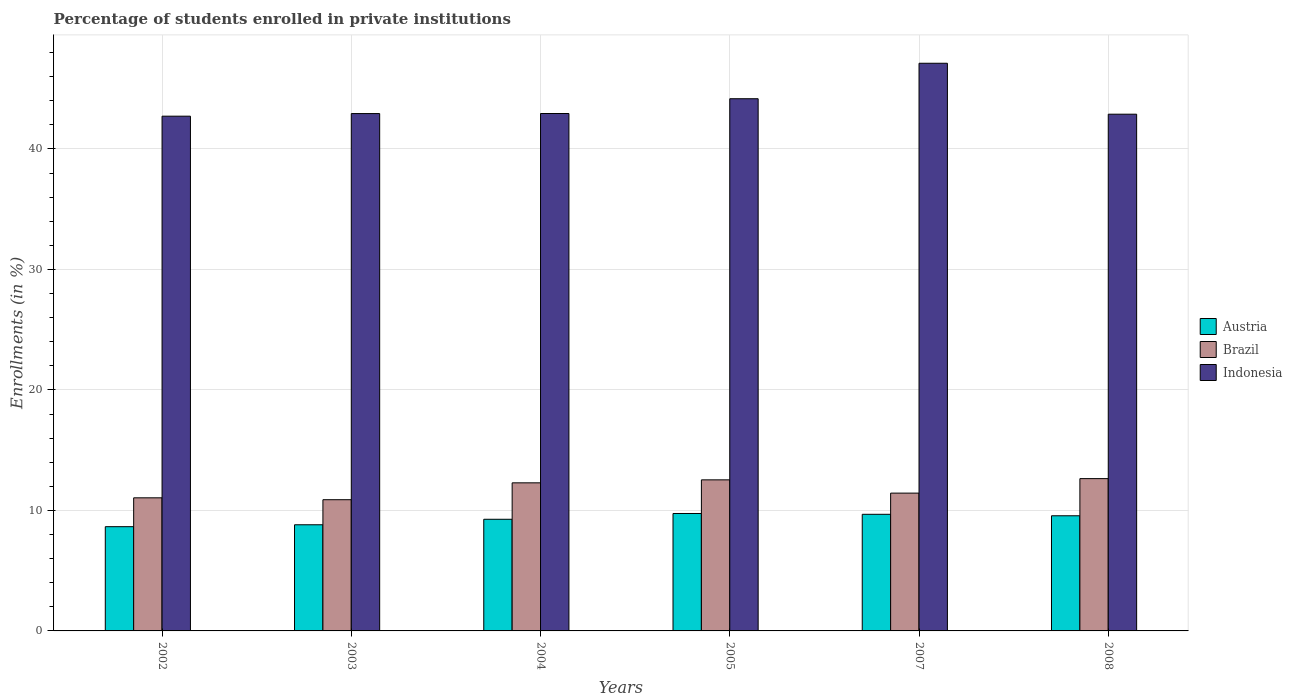Are the number of bars per tick equal to the number of legend labels?
Your answer should be very brief. Yes. Are the number of bars on each tick of the X-axis equal?
Make the answer very short. Yes. How many bars are there on the 4th tick from the right?
Your response must be concise. 3. What is the label of the 1st group of bars from the left?
Offer a very short reply. 2002. In how many cases, is the number of bars for a given year not equal to the number of legend labels?
Give a very brief answer. 0. What is the percentage of trained teachers in Austria in 2002?
Give a very brief answer. 8.65. Across all years, what is the maximum percentage of trained teachers in Brazil?
Ensure brevity in your answer.  12.64. Across all years, what is the minimum percentage of trained teachers in Brazil?
Provide a short and direct response. 10.89. In which year was the percentage of trained teachers in Austria maximum?
Your answer should be very brief. 2005. In which year was the percentage of trained teachers in Austria minimum?
Your response must be concise. 2002. What is the total percentage of trained teachers in Austria in the graph?
Keep it short and to the point. 55.71. What is the difference between the percentage of trained teachers in Austria in 2004 and that in 2007?
Provide a short and direct response. -0.41. What is the difference between the percentage of trained teachers in Indonesia in 2007 and the percentage of trained teachers in Brazil in 2002?
Offer a terse response. 36.07. What is the average percentage of trained teachers in Brazil per year?
Offer a very short reply. 11.81. In the year 2005, what is the difference between the percentage of trained teachers in Austria and percentage of trained teachers in Brazil?
Provide a short and direct response. -2.79. What is the ratio of the percentage of trained teachers in Austria in 2003 to that in 2008?
Provide a succinct answer. 0.92. What is the difference between the highest and the second highest percentage of trained teachers in Brazil?
Give a very brief answer. 0.1. What is the difference between the highest and the lowest percentage of trained teachers in Brazil?
Provide a succinct answer. 1.75. What does the 1st bar from the left in 2008 represents?
Provide a short and direct response. Austria. What does the 2nd bar from the right in 2005 represents?
Provide a short and direct response. Brazil. What is the difference between two consecutive major ticks on the Y-axis?
Give a very brief answer. 10. Are the values on the major ticks of Y-axis written in scientific E-notation?
Provide a succinct answer. No. Does the graph contain any zero values?
Provide a succinct answer. No. Does the graph contain grids?
Give a very brief answer. Yes. How many legend labels are there?
Ensure brevity in your answer.  3. How are the legend labels stacked?
Keep it short and to the point. Vertical. What is the title of the graph?
Make the answer very short. Percentage of students enrolled in private institutions. Does "Channel Islands" appear as one of the legend labels in the graph?
Give a very brief answer. No. What is the label or title of the Y-axis?
Keep it short and to the point. Enrollments (in %). What is the Enrollments (in %) of Austria in 2002?
Your answer should be very brief. 8.65. What is the Enrollments (in %) of Brazil in 2002?
Provide a succinct answer. 11.05. What is the Enrollments (in %) in Indonesia in 2002?
Ensure brevity in your answer.  42.72. What is the Enrollments (in %) of Austria in 2003?
Offer a terse response. 8.81. What is the Enrollments (in %) of Brazil in 2003?
Keep it short and to the point. 10.89. What is the Enrollments (in %) of Indonesia in 2003?
Ensure brevity in your answer.  42.94. What is the Enrollments (in %) in Austria in 2004?
Your answer should be compact. 9.27. What is the Enrollments (in %) in Brazil in 2004?
Your response must be concise. 12.29. What is the Enrollments (in %) of Indonesia in 2004?
Keep it short and to the point. 42.94. What is the Enrollments (in %) of Austria in 2005?
Provide a short and direct response. 9.75. What is the Enrollments (in %) in Brazil in 2005?
Your answer should be compact. 12.54. What is the Enrollments (in %) in Indonesia in 2005?
Provide a short and direct response. 44.17. What is the Enrollments (in %) of Austria in 2007?
Your response must be concise. 9.68. What is the Enrollments (in %) in Brazil in 2007?
Your response must be concise. 11.44. What is the Enrollments (in %) of Indonesia in 2007?
Your answer should be compact. 47.11. What is the Enrollments (in %) in Austria in 2008?
Your response must be concise. 9.56. What is the Enrollments (in %) in Brazil in 2008?
Your answer should be compact. 12.64. What is the Enrollments (in %) in Indonesia in 2008?
Provide a short and direct response. 42.89. Across all years, what is the maximum Enrollments (in %) in Austria?
Your answer should be very brief. 9.75. Across all years, what is the maximum Enrollments (in %) of Brazil?
Make the answer very short. 12.64. Across all years, what is the maximum Enrollments (in %) of Indonesia?
Offer a very short reply. 47.11. Across all years, what is the minimum Enrollments (in %) in Austria?
Your response must be concise. 8.65. Across all years, what is the minimum Enrollments (in %) of Brazil?
Your response must be concise. 10.89. Across all years, what is the minimum Enrollments (in %) of Indonesia?
Your answer should be very brief. 42.72. What is the total Enrollments (in %) in Austria in the graph?
Your answer should be compact. 55.71. What is the total Enrollments (in %) in Brazil in the graph?
Keep it short and to the point. 70.84. What is the total Enrollments (in %) in Indonesia in the graph?
Provide a short and direct response. 262.77. What is the difference between the Enrollments (in %) of Austria in 2002 and that in 2003?
Provide a succinct answer. -0.16. What is the difference between the Enrollments (in %) in Brazil in 2002 and that in 2003?
Provide a short and direct response. 0.16. What is the difference between the Enrollments (in %) in Indonesia in 2002 and that in 2003?
Give a very brief answer. -0.22. What is the difference between the Enrollments (in %) in Austria in 2002 and that in 2004?
Offer a very short reply. -0.61. What is the difference between the Enrollments (in %) in Brazil in 2002 and that in 2004?
Your answer should be very brief. -1.24. What is the difference between the Enrollments (in %) in Indonesia in 2002 and that in 2004?
Give a very brief answer. -0.22. What is the difference between the Enrollments (in %) of Austria in 2002 and that in 2005?
Offer a very short reply. -1.09. What is the difference between the Enrollments (in %) in Brazil in 2002 and that in 2005?
Offer a very short reply. -1.49. What is the difference between the Enrollments (in %) in Indonesia in 2002 and that in 2005?
Offer a terse response. -1.45. What is the difference between the Enrollments (in %) in Austria in 2002 and that in 2007?
Make the answer very short. -1.03. What is the difference between the Enrollments (in %) of Brazil in 2002 and that in 2007?
Provide a succinct answer. -0.39. What is the difference between the Enrollments (in %) of Indonesia in 2002 and that in 2007?
Offer a very short reply. -4.39. What is the difference between the Enrollments (in %) in Austria in 2002 and that in 2008?
Your answer should be very brief. -0.91. What is the difference between the Enrollments (in %) of Brazil in 2002 and that in 2008?
Your answer should be compact. -1.59. What is the difference between the Enrollments (in %) of Indonesia in 2002 and that in 2008?
Offer a very short reply. -0.16. What is the difference between the Enrollments (in %) in Austria in 2003 and that in 2004?
Offer a very short reply. -0.46. What is the difference between the Enrollments (in %) in Brazil in 2003 and that in 2004?
Make the answer very short. -1.4. What is the difference between the Enrollments (in %) in Indonesia in 2003 and that in 2004?
Your answer should be very brief. -0. What is the difference between the Enrollments (in %) in Austria in 2003 and that in 2005?
Your response must be concise. -0.94. What is the difference between the Enrollments (in %) in Brazil in 2003 and that in 2005?
Your answer should be compact. -1.65. What is the difference between the Enrollments (in %) of Indonesia in 2003 and that in 2005?
Offer a terse response. -1.23. What is the difference between the Enrollments (in %) of Austria in 2003 and that in 2007?
Keep it short and to the point. -0.87. What is the difference between the Enrollments (in %) in Brazil in 2003 and that in 2007?
Provide a short and direct response. -0.55. What is the difference between the Enrollments (in %) in Indonesia in 2003 and that in 2007?
Ensure brevity in your answer.  -4.18. What is the difference between the Enrollments (in %) of Austria in 2003 and that in 2008?
Provide a succinct answer. -0.75. What is the difference between the Enrollments (in %) of Brazil in 2003 and that in 2008?
Provide a short and direct response. -1.75. What is the difference between the Enrollments (in %) in Indonesia in 2003 and that in 2008?
Your response must be concise. 0.05. What is the difference between the Enrollments (in %) of Austria in 2004 and that in 2005?
Provide a short and direct response. -0.48. What is the difference between the Enrollments (in %) of Brazil in 2004 and that in 2005?
Give a very brief answer. -0.25. What is the difference between the Enrollments (in %) in Indonesia in 2004 and that in 2005?
Provide a succinct answer. -1.23. What is the difference between the Enrollments (in %) in Austria in 2004 and that in 2007?
Offer a terse response. -0.41. What is the difference between the Enrollments (in %) of Brazil in 2004 and that in 2007?
Provide a succinct answer. 0.85. What is the difference between the Enrollments (in %) in Indonesia in 2004 and that in 2007?
Provide a short and direct response. -4.17. What is the difference between the Enrollments (in %) of Austria in 2004 and that in 2008?
Ensure brevity in your answer.  -0.29. What is the difference between the Enrollments (in %) of Brazil in 2004 and that in 2008?
Your response must be concise. -0.35. What is the difference between the Enrollments (in %) in Indonesia in 2004 and that in 2008?
Make the answer very short. 0.06. What is the difference between the Enrollments (in %) of Austria in 2005 and that in 2007?
Your response must be concise. 0.07. What is the difference between the Enrollments (in %) in Brazil in 2005 and that in 2007?
Provide a short and direct response. 1.1. What is the difference between the Enrollments (in %) of Indonesia in 2005 and that in 2007?
Give a very brief answer. -2.94. What is the difference between the Enrollments (in %) in Austria in 2005 and that in 2008?
Provide a succinct answer. 0.19. What is the difference between the Enrollments (in %) in Brazil in 2005 and that in 2008?
Your answer should be compact. -0.1. What is the difference between the Enrollments (in %) of Indonesia in 2005 and that in 2008?
Make the answer very short. 1.28. What is the difference between the Enrollments (in %) in Austria in 2007 and that in 2008?
Provide a succinct answer. 0.12. What is the difference between the Enrollments (in %) in Brazil in 2007 and that in 2008?
Your answer should be very brief. -1.2. What is the difference between the Enrollments (in %) of Indonesia in 2007 and that in 2008?
Your response must be concise. 4.23. What is the difference between the Enrollments (in %) of Austria in 2002 and the Enrollments (in %) of Brazil in 2003?
Offer a terse response. -2.24. What is the difference between the Enrollments (in %) in Austria in 2002 and the Enrollments (in %) in Indonesia in 2003?
Your response must be concise. -34.29. What is the difference between the Enrollments (in %) in Brazil in 2002 and the Enrollments (in %) in Indonesia in 2003?
Your response must be concise. -31.89. What is the difference between the Enrollments (in %) in Austria in 2002 and the Enrollments (in %) in Brazil in 2004?
Offer a very short reply. -3.64. What is the difference between the Enrollments (in %) in Austria in 2002 and the Enrollments (in %) in Indonesia in 2004?
Ensure brevity in your answer.  -34.29. What is the difference between the Enrollments (in %) in Brazil in 2002 and the Enrollments (in %) in Indonesia in 2004?
Your response must be concise. -31.9. What is the difference between the Enrollments (in %) of Austria in 2002 and the Enrollments (in %) of Brazil in 2005?
Offer a terse response. -3.89. What is the difference between the Enrollments (in %) in Austria in 2002 and the Enrollments (in %) in Indonesia in 2005?
Your response must be concise. -35.52. What is the difference between the Enrollments (in %) in Brazil in 2002 and the Enrollments (in %) in Indonesia in 2005?
Provide a succinct answer. -33.12. What is the difference between the Enrollments (in %) in Austria in 2002 and the Enrollments (in %) in Brazil in 2007?
Your answer should be compact. -2.79. What is the difference between the Enrollments (in %) in Austria in 2002 and the Enrollments (in %) in Indonesia in 2007?
Your response must be concise. -38.46. What is the difference between the Enrollments (in %) of Brazil in 2002 and the Enrollments (in %) of Indonesia in 2007?
Provide a succinct answer. -36.07. What is the difference between the Enrollments (in %) of Austria in 2002 and the Enrollments (in %) of Brazil in 2008?
Offer a terse response. -3.99. What is the difference between the Enrollments (in %) in Austria in 2002 and the Enrollments (in %) in Indonesia in 2008?
Keep it short and to the point. -34.23. What is the difference between the Enrollments (in %) of Brazil in 2002 and the Enrollments (in %) of Indonesia in 2008?
Offer a very short reply. -31.84. What is the difference between the Enrollments (in %) of Austria in 2003 and the Enrollments (in %) of Brazil in 2004?
Ensure brevity in your answer.  -3.48. What is the difference between the Enrollments (in %) in Austria in 2003 and the Enrollments (in %) in Indonesia in 2004?
Offer a terse response. -34.13. What is the difference between the Enrollments (in %) of Brazil in 2003 and the Enrollments (in %) of Indonesia in 2004?
Give a very brief answer. -32.05. What is the difference between the Enrollments (in %) in Austria in 2003 and the Enrollments (in %) in Brazil in 2005?
Your answer should be very brief. -3.73. What is the difference between the Enrollments (in %) in Austria in 2003 and the Enrollments (in %) in Indonesia in 2005?
Keep it short and to the point. -35.36. What is the difference between the Enrollments (in %) in Brazil in 2003 and the Enrollments (in %) in Indonesia in 2005?
Provide a short and direct response. -33.28. What is the difference between the Enrollments (in %) of Austria in 2003 and the Enrollments (in %) of Brazil in 2007?
Keep it short and to the point. -2.63. What is the difference between the Enrollments (in %) of Austria in 2003 and the Enrollments (in %) of Indonesia in 2007?
Ensure brevity in your answer.  -38.3. What is the difference between the Enrollments (in %) of Brazil in 2003 and the Enrollments (in %) of Indonesia in 2007?
Provide a succinct answer. -36.22. What is the difference between the Enrollments (in %) in Austria in 2003 and the Enrollments (in %) in Brazil in 2008?
Give a very brief answer. -3.83. What is the difference between the Enrollments (in %) in Austria in 2003 and the Enrollments (in %) in Indonesia in 2008?
Provide a succinct answer. -34.08. What is the difference between the Enrollments (in %) in Brazil in 2003 and the Enrollments (in %) in Indonesia in 2008?
Offer a terse response. -32. What is the difference between the Enrollments (in %) in Austria in 2004 and the Enrollments (in %) in Brazil in 2005?
Keep it short and to the point. -3.27. What is the difference between the Enrollments (in %) of Austria in 2004 and the Enrollments (in %) of Indonesia in 2005?
Offer a very short reply. -34.9. What is the difference between the Enrollments (in %) of Brazil in 2004 and the Enrollments (in %) of Indonesia in 2005?
Provide a short and direct response. -31.88. What is the difference between the Enrollments (in %) in Austria in 2004 and the Enrollments (in %) in Brazil in 2007?
Your answer should be very brief. -2.17. What is the difference between the Enrollments (in %) in Austria in 2004 and the Enrollments (in %) in Indonesia in 2007?
Your answer should be very brief. -37.85. What is the difference between the Enrollments (in %) of Brazil in 2004 and the Enrollments (in %) of Indonesia in 2007?
Your response must be concise. -34.82. What is the difference between the Enrollments (in %) of Austria in 2004 and the Enrollments (in %) of Brazil in 2008?
Your answer should be very brief. -3.37. What is the difference between the Enrollments (in %) in Austria in 2004 and the Enrollments (in %) in Indonesia in 2008?
Give a very brief answer. -33.62. What is the difference between the Enrollments (in %) in Brazil in 2004 and the Enrollments (in %) in Indonesia in 2008?
Provide a succinct answer. -30.6. What is the difference between the Enrollments (in %) of Austria in 2005 and the Enrollments (in %) of Brazil in 2007?
Keep it short and to the point. -1.69. What is the difference between the Enrollments (in %) of Austria in 2005 and the Enrollments (in %) of Indonesia in 2007?
Give a very brief answer. -37.37. What is the difference between the Enrollments (in %) of Brazil in 2005 and the Enrollments (in %) of Indonesia in 2007?
Your answer should be very brief. -34.58. What is the difference between the Enrollments (in %) in Austria in 2005 and the Enrollments (in %) in Brazil in 2008?
Give a very brief answer. -2.89. What is the difference between the Enrollments (in %) in Austria in 2005 and the Enrollments (in %) in Indonesia in 2008?
Offer a very short reply. -33.14. What is the difference between the Enrollments (in %) of Brazil in 2005 and the Enrollments (in %) of Indonesia in 2008?
Your answer should be compact. -30.35. What is the difference between the Enrollments (in %) of Austria in 2007 and the Enrollments (in %) of Brazil in 2008?
Your answer should be very brief. -2.96. What is the difference between the Enrollments (in %) of Austria in 2007 and the Enrollments (in %) of Indonesia in 2008?
Your answer should be very brief. -33.21. What is the difference between the Enrollments (in %) of Brazil in 2007 and the Enrollments (in %) of Indonesia in 2008?
Offer a very short reply. -31.45. What is the average Enrollments (in %) in Austria per year?
Your answer should be very brief. 9.29. What is the average Enrollments (in %) in Brazil per year?
Your answer should be very brief. 11.81. What is the average Enrollments (in %) of Indonesia per year?
Give a very brief answer. 43.79. In the year 2002, what is the difference between the Enrollments (in %) of Austria and Enrollments (in %) of Brazil?
Give a very brief answer. -2.39. In the year 2002, what is the difference between the Enrollments (in %) of Austria and Enrollments (in %) of Indonesia?
Offer a very short reply. -34.07. In the year 2002, what is the difference between the Enrollments (in %) of Brazil and Enrollments (in %) of Indonesia?
Your response must be concise. -31.67. In the year 2003, what is the difference between the Enrollments (in %) in Austria and Enrollments (in %) in Brazil?
Offer a terse response. -2.08. In the year 2003, what is the difference between the Enrollments (in %) in Austria and Enrollments (in %) in Indonesia?
Offer a very short reply. -34.13. In the year 2003, what is the difference between the Enrollments (in %) in Brazil and Enrollments (in %) in Indonesia?
Your answer should be compact. -32.05. In the year 2004, what is the difference between the Enrollments (in %) of Austria and Enrollments (in %) of Brazil?
Offer a very short reply. -3.02. In the year 2004, what is the difference between the Enrollments (in %) of Austria and Enrollments (in %) of Indonesia?
Give a very brief answer. -33.68. In the year 2004, what is the difference between the Enrollments (in %) in Brazil and Enrollments (in %) in Indonesia?
Keep it short and to the point. -30.65. In the year 2005, what is the difference between the Enrollments (in %) in Austria and Enrollments (in %) in Brazil?
Give a very brief answer. -2.79. In the year 2005, what is the difference between the Enrollments (in %) of Austria and Enrollments (in %) of Indonesia?
Your response must be concise. -34.42. In the year 2005, what is the difference between the Enrollments (in %) of Brazil and Enrollments (in %) of Indonesia?
Your answer should be very brief. -31.63. In the year 2007, what is the difference between the Enrollments (in %) of Austria and Enrollments (in %) of Brazil?
Make the answer very short. -1.76. In the year 2007, what is the difference between the Enrollments (in %) in Austria and Enrollments (in %) in Indonesia?
Your response must be concise. -37.43. In the year 2007, what is the difference between the Enrollments (in %) in Brazil and Enrollments (in %) in Indonesia?
Make the answer very short. -35.68. In the year 2008, what is the difference between the Enrollments (in %) of Austria and Enrollments (in %) of Brazil?
Your answer should be very brief. -3.08. In the year 2008, what is the difference between the Enrollments (in %) of Austria and Enrollments (in %) of Indonesia?
Offer a very short reply. -33.33. In the year 2008, what is the difference between the Enrollments (in %) of Brazil and Enrollments (in %) of Indonesia?
Offer a terse response. -30.24. What is the ratio of the Enrollments (in %) in Austria in 2002 to that in 2003?
Your response must be concise. 0.98. What is the ratio of the Enrollments (in %) in Brazil in 2002 to that in 2003?
Your response must be concise. 1.01. What is the ratio of the Enrollments (in %) of Austria in 2002 to that in 2004?
Your answer should be compact. 0.93. What is the ratio of the Enrollments (in %) of Brazil in 2002 to that in 2004?
Provide a succinct answer. 0.9. What is the ratio of the Enrollments (in %) in Indonesia in 2002 to that in 2004?
Provide a short and direct response. 0.99. What is the ratio of the Enrollments (in %) of Austria in 2002 to that in 2005?
Provide a short and direct response. 0.89. What is the ratio of the Enrollments (in %) of Brazil in 2002 to that in 2005?
Offer a very short reply. 0.88. What is the ratio of the Enrollments (in %) in Indonesia in 2002 to that in 2005?
Your answer should be very brief. 0.97. What is the ratio of the Enrollments (in %) of Austria in 2002 to that in 2007?
Keep it short and to the point. 0.89. What is the ratio of the Enrollments (in %) in Brazil in 2002 to that in 2007?
Your answer should be compact. 0.97. What is the ratio of the Enrollments (in %) of Indonesia in 2002 to that in 2007?
Your answer should be compact. 0.91. What is the ratio of the Enrollments (in %) of Austria in 2002 to that in 2008?
Offer a very short reply. 0.91. What is the ratio of the Enrollments (in %) in Brazil in 2002 to that in 2008?
Provide a short and direct response. 0.87. What is the ratio of the Enrollments (in %) of Indonesia in 2002 to that in 2008?
Make the answer very short. 1. What is the ratio of the Enrollments (in %) of Austria in 2003 to that in 2004?
Make the answer very short. 0.95. What is the ratio of the Enrollments (in %) of Brazil in 2003 to that in 2004?
Ensure brevity in your answer.  0.89. What is the ratio of the Enrollments (in %) in Austria in 2003 to that in 2005?
Offer a terse response. 0.9. What is the ratio of the Enrollments (in %) in Brazil in 2003 to that in 2005?
Your answer should be compact. 0.87. What is the ratio of the Enrollments (in %) of Indonesia in 2003 to that in 2005?
Your answer should be very brief. 0.97. What is the ratio of the Enrollments (in %) in Austria in 2003 to that in 2007?
Offer a terse response. 0.91. What is the ratio of the Enrollments (in %) of Brazil in 2003 to that in 2007?
Provide a succinct answer. 0.95. What is the ratio of the Enrollments (in %) in Indonesia in 2003 to that in 2007?
Ensure brevity in your answer.  0.91. What is the ratio of the Enrollments (in %) in Austria in 2003 to that in 2008?
Your answer should be very brief. 0.92. What is the ratio of the Enrollments (in %) in Brazil in 2003 to that in 2008?
Give a very brief answer. 0.86. What is the ratio of the Enrollments (in %) of Austria in 2004 to that in 2005?
Give a very brief answer. 0.95. What is the ratio of the Enrollments (in %) in Brazil in 2004 to that in 2005?
Ensure brevity in your answer.  0.98. What is the ratio of the Enrollments (in %) of Indonesia in 2004 to that in 2005?
Ensure brevity in your answer.  0.97. What is the ratio of the Enrollments (in %) in Austria in 2004 to that in 2007?
Offer a terse response. 0.96. What is the ratio of the Enrollments (in %) of Brazil in 2004 to that in 2007?
Your answer should be compact. 1.07. What is the ratio of the Enrollments (in %) of Indonesia in 2004 to that in 2007?
Offer a very short reply. 0.91. What is the ratio of the Enrollments (in %) of Austria in 2004 to that in 2008?
Your answer should be very brief. 0.97. What is the ratio of the Enrollments (in %) in Brazil in 2004 to that in 2008?
Provide a succinct answer. 0.97. What is the ratio of the Enrollments (in %) in Indonesia in 2004 to that in 2008?
Your response must be concise. 1. What is the ratio of the Enrollments (in %) of Austria in 2005 to that in 2007?
Ensure brevity in your answer.  1.01. What is the ratio of the Enrollments (in %) in Brazil in 2005 to that in 2007?
Give a very brief answer. 1.1. What is the ratio of the Enrollments (in %) in Indonesia in 2005 to that in 2007?
Your answer should be compact. 0.94. What is the ratio of the Enrollments (in %) of Austria in 2005 to that in 2008?
Your answer should be very brief. 1.02. What is the ratio of the Enrollments (in %) of Indonesia in 2005 to that in 2008?
Provide a short and direct response. 1.03. What is the ratio of the Enrollments (in %) in Austria in 2007 to that in 2008?
Keep it short and to the point. 1.01. What is the ratio of the Enrollments (in %) in Brazil in 2007 to that in 2008?
Offer a terse response. 0.9. What is the ratio of the Enrollments (in %) in Indonesia in 2007 to that in 2008?
Give a very brief answer. 1.1. What is the difference between the highest and the second highest Enrollments (in %) of Austria?
Give a very brief answer. 0.07. What is the difference between the highest and the second highest Enrollments (in %) in Brazil?
Your answer should be very brief. 0.1. What is the difference between the highest and the second highest Enrollments (in %) of Indonesia?
Your answer should be very brief. 2.94. What is the difference between the highest and the lowest Enrollments (in %) of Austria?
Give a very brief answer. 1.09. What is the difference between the highest and the lowest Enrollments (in %) in Brazil?
Offer a very short reply. 1.75. What is the difference between the highest and the lowest Enrollments (in %) in Indonesia?
Make the answer very short. 4.39. 